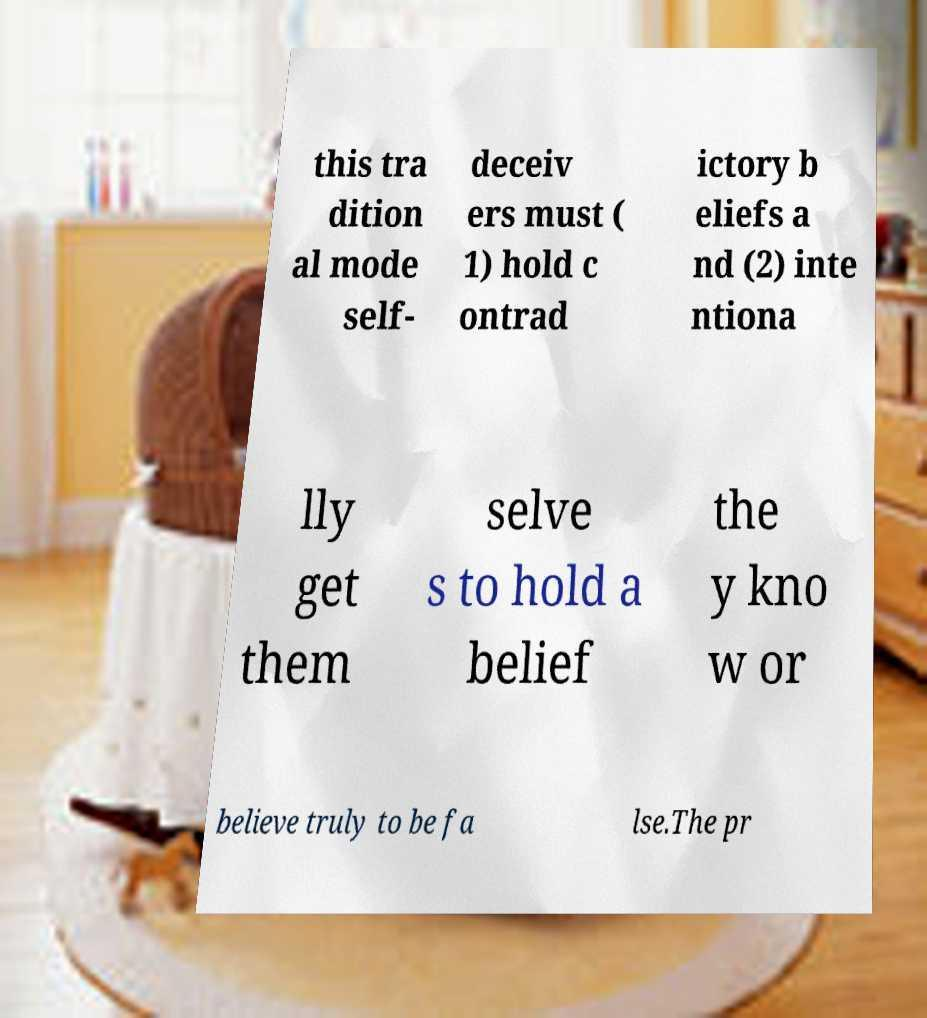Can you read and provide the text displayed in the image?This photo seems to have some interesting text. Can you extract and type it out for me? this tra dition al mode self- deceiv ers must ( 1) hold c ontrad ictory b eliefs a nd (2) inte ntiona lly get them selve s to hold a belief the y kno w or believe truly to be fa lse.The pr 